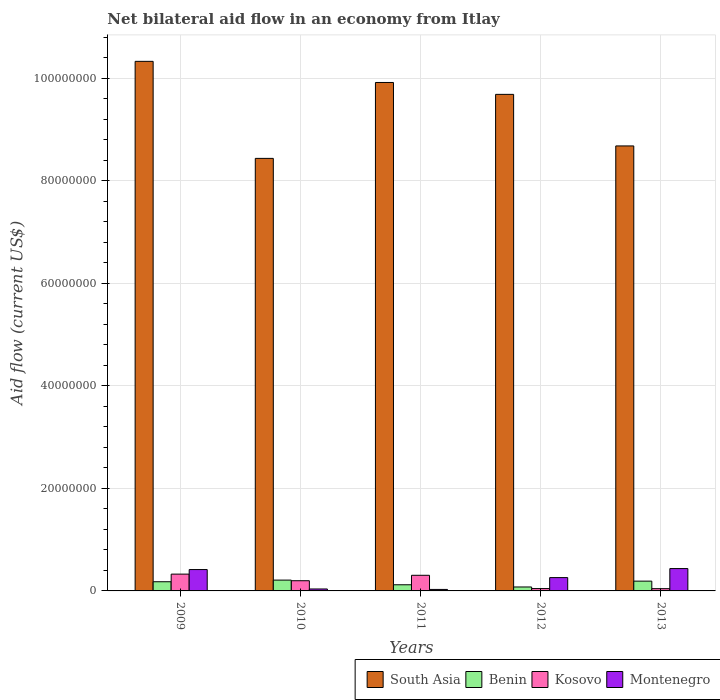How many groups of bars are there?
Provide a succinct answer. 5. How many bars are there on the 5th tick from the left?
Offer a terse response. 4. How many bars are there on the 4th tick from the right?
Your answer should be compact. 4. What is the net bilateral aid flow in Benin in 2009?
Your answer should be very brief. 1.79e+06. Across all years, what is the maximum net bilateral aid flow in Benin?
Keep it short and to the point. 2.11e+06. Across all years, what is the minimum net bilateral aid flow in South Asia?
Keep it short and to the point. 8.44e+07. In which year was the net bilateral aid flow in South Asia maximum?
Ensure brevity in your answer.  2009. What is the total net bilateral aid flow in Kosovo in the graph?
Offer a terse response. 9.22e+06. What is the difference between the net bilateral aid flow in Kosovo in 2011 and that in 2012?
Give a very brief answer. 2.59e+06. What is the difference between the net bilateral aid flow in Montenegro in 2011 and the net bilateral aid flow in Kosovo in 2010?
Provide a succinct answer. -1.70e+06. What is the average net bilateral aid flow in Kosovo per year?
Ensure brevity in your answer.  1.84e+06. In the year 2009, what is the difference between the net bilateral aid flow in Benin and net bilateral aid flow in Kosovo?
Offer a very short reply. -1.49e+06. In how many years, is the net bilateral aid flow in Benin greater than 32000000 US$?
Ensure brevity in your answer.  0. What is the ratio of the net bilateral aid flow in Kosovo in 2009 to that in 2011?
Ensure brevity in your answer.  1.08. Is the net bilateral aid flow in Kosovo in 2010 less than that in 2013?
Offer a very short reply. No. What is the difference between the highest and the second highest net bilateral aid flow in Kosovo?
Offer a terse response. 2.30e+05. What is the difference between the highest and the lowest net bilateral aid flow in Benin?
Your answer should be compact. 1.34e+06. What does the 2nd bar from the left in 2012 represents?
Make the answer very short. Benin. What does the 2nd bar from the right in 2009 represents?
Ensure brevity in your answer.  Kosovo. Are all the bars in the graph horizontal?
Give a very brief answer. No. How many years are there in the graph?
Ensure brevity in your answer.  5. Are the values on the major ticks of Y-axis written in scientific E-notation?
Offer a very short reply. No. How many legend labels are there?
Make the answer very short. 4. How are the legend labels stacked?
Your response must be concise. Horizontal. What is the title of the graph?
Offer a terse response. Net bilateral aid flow in an economy from Itlay. Does "Greece" appear as one of the legend labels in the graph?
Make the answer very short. No. What is the label or title of the X-axis?
Offer a terse response. Years. What is the label or title of the Y-axis?
Ensure brevity in your answer.  Aid flow (current US$). What is the Aid flow (current US$) of South Asia in 2009?
Keep it short and to the point. 1.03e+08. What is the Aid flow (current US$) of Benin in 2009?
Ensure brevity in your answer.  1.79e+06. What is the Aid flow (current US$) of Kosovo in 2009?
Offer a terse response. 3.28e+06. What is the Aid flow (current US$) of Montenegro in 2009?
Provide a succinct answer. 4.17e+06. What is the Aid flow (current US$) in South Asia in 2010?
Your answer should be very brief. 8.44e+07. What is the Aid flow (current US$) in Benin in 2010?
Provide a short and direct response. 2.11e+06. What is the Aid flow (current US$) of Kosovo in 2010?
Provide a succinct answer. 1.99e+06. What is the Aid flow (current US$) of South Asia in 2011?
Offer a terse response. 9.92e+07. What is the Aid flow (current US$) in Benin in 2011?
Your response must be concise. 1.20e+06. What is the Aid flow (current US$) in Kosovo in 2011?
Give a very brief answer. 3.05e+06. What is the Aid flow (current US$) of Montenegro in 2011?
Provide a short and direct response. 2.90e+05. What is the Aid flow (current US$) of South Asia in 2012?
Your response must be concise. 9.69e+07. What is the Aid flow (current US$) of Benin in 2012?
Make the answer very short. 7.70e+05. What is the Aid flow (current US$) in Montenegro in 2012?
Your answer should be very brief. 2.60e+06. What is the Aid flow (current US$) in South Asia in 2013?
Keep it short and to the point. 8.68e+07. What is the Aid flow (current US$) of Benin in 2013?
Your response must be concise. 1.91e+06. What is the Aid flow (current US$) in Montenegro in 2013?
Offer a terse response. 4.36e+06. Across all years, what is the maximum Aid flow (current US$) in South Asia?
Offer a terse response. 1.03e+08. Across all years, what is the maximum Aid flow (current US$) of Benin?
Give a very brief answer. 2.11e+06. Across all years, what is the maximum Aid flow (current US$) of Kosovo?
Make the answer very short. 3.28e+06. Across all years, what is the maximum Aid flow (current US$) in Montenegro?
Keep it short and to the point. 4.36e+06. Across all years, what is the minimum Aid flow (current US$) in South Asia?
Make the answer very short. 8.44e+07. Across all years, what is the minimum Aid flow (current US$) of Benin?
Offer a terse response. 7.70e+05. Across all years, what is the minimum Aid flow (current US$) of Montenegro?
Provide a short and direct response. 2.90e+05. What is the total Aid flow (current US$) in South Asia in the graph?
Offer a terse response. 4.71e+08. What is the total Aid flow (current US$) of Benin in the graph?
Provide a short and direct response. 7.78e+06. What is the total Aid flow (current US$) of Kosovo in the graph?
Give a very brief answer. 9.22e+06. What is the total Aid flow (current US$) of Montenegro in the graph?
Give a very brief answer. 1.18e+07. What is the difference between the Aid flow (current US$) in South Asia in 2009 and that in 2010?
Provide a short and direct response. 1.89e+07. What is the difference between the Aid flow (current US$) in Benin in 2009 and that in 2010?
Your response must be concise. -3.20e+05. What is the difference between the Aid flow (current US$) of Kosovo in 2009 and that in 2010?
Offer a very short reply. 1.29e+06. What is the difference between the Aid flow (current US$) of Montenegro in 2009 and that in 2010?
Your answer should be very brief. 3.79e+06. What is the difference between the Aid flow (current US$) of South Asia in 2009 and that in 2011?
Give a very brief answer. 4.12e+06. What is the difference between the Aid flow (current US$) of Benin in 2009 and that in 2011?
Offer a very short reply. 5.90e+05. What is the difference between the Aid flow (current US$) in Kosovo in 2009 and that in 2011?
Keep it short and to the point. 2.30e+05. What is the difference between the Aid flow (current US$) of Montenegro in 2009 and that in 2011?
Offer a terse response. 3.88e+06. What is the difference between the Aid flow (current US$) of South Asia in 2009 and that in 2012?
Your response must be concise. 6.44e+06. What is the difference between the Aid flow (current US$) of Benin in 2009 and that in 2012?
Offer a very short reply. 1.02e+06. What is the difference between the Aid flow (current US$) in Kosovo in 2009 and that in 2012?
Provide a short and direct response. 2.82e+06. What is the difference between the Aid flow (current US$) of Montenegro in 2009 and that in 2012?
Give a very brief answer. 1.57e+06. What is the difference between the Aid flow (current US$) of South Asia in 2009 and that in 2013?
Make the answer very short. 1.65e+07. What is the difference between the Aid flow (current US$) of Kosovo in 2009 and that in 2013?
Your response must be concise. 2.84e+06. What is the difference between the Aid flow (current US$) of South Asia in 2010 and that in 2011?
Your response must be concise. -1.48e+07. What is the difference between the Aid flow (current US$) in Benin in 2010 and that in 2011?
Your answer should be very brief. 9.10e+05. What is the difference between the Aid flow (current US$) of Kosovo in 2010 and that in 2011?
Provide a short and direct response. -1.06e+06. What is the difference between the Aid flow (current US$) in Montenegro in 2010 and that in 2011?
Your answer should be compact. 9.00e+04. What is the difference between the Aid flow (current US$) of South Asia in 2010 and that in 2012?
Make the answer very short. -1.25e+07. What is the difference between the Aid flow (current US$) of Benin in 2010 and that in 2012?
Keep it short and to the point. 1.34e+06. What is the difference between the Aid flow (current US$) in Kosovo in 2010 and that in 2012?
Give a very brief answer. 1.53e+06. What is the difference between the Aid flow (current US$) of Montenegro in 2010 and that in 2012?
Make the answer very short. -2.22e+06. What is the difference between the Aid flow (current US$) of South Asia in 2010 and that in 2013?
Your answer should be compact. -2.43e+06. What is the difference between the Aid flow (current US$) of Benin in 2010 and that in 2013?
Offer a terse response. 2.00e+05. What is the difference between the Aid flow (current US$) in Kosovo in 2010 and that in 2013?
Make the answer very short. 1.55e+06. What is the difference between the Aid flow (current US$) in Montenegro in 2010 and that in 2013?
Provide a succinct answer. -3.98e+06. What is the difference between the Aid flow (current US$) of South Asia in 2011 and that in 2012?
Give a very brief answer. 2.32e+06. What is the difference between the Aid flow (current US$) in Benin in 2011 and that in 2012?
Make the answer very short. 4.30e+05. What is the difference between the Aid flow (current US$) in Kosovo in 2011 and that in 2012?
Make the answer very short. 2.59e+06. What is the difference between the Aid flow (current US$) of Montenegro in 2011 and that in 2012?
Your answer should be very brief. -2.31e+06. What is the difference between the Aid flow (current US$) in South Asia in 2011 and that in 2013?
Your answer should be very brief. 1.24e+07. What is the difference between the Aid flow (current US$) in Benin in 2011 and that in 2013?
Give a very brief answer. -7.10e+05. What is the difference between the Aid flow (current US$) of Kosovo in 2011 and that in 2013?
Your answer should be compact. 2.61e+06. What is the difference between the Aid flow (current US$) of Montenegro in 2011 and that in 2013?
Your response must be concise. -4.07e+06. What is the difference between the Aid flow (current US$) of South Asia in 2012 and that in 2013?
Make the answer very short. 1.01e+07. What is the difference between the Aid flow (current US$) in Benin in 2012 and that in 2013?
Offer a terse response. -1.14e+06. What is the difference between the Aid flow (current US$) in Montenegro in 2012 and that in 2013?
Your answer should be compact. -1.76e+06. What is the difference between the Aid flow (current US$) of South Asia in 2009 and the Aid flow (current US$) of Benin in 2010?
Your answer should be compact. 1.01e+08. What is the difference between the Aid flow (current US$) in South Asia in 2009 and the Aid flow (current US$) in Kosovo in 2010?
Offer a terse response. 1.01e+08. What is the difference between the Aid flow (current US$) of South Asia in 2009 and the Aid flow (current US$) of Montenegro in 2010?
Your answer should be compact. 1.03e+08. What is the difference between the Aid flow (current US$) of Benin in 2009 and the Aid flow (current US$) of Kosovo in 2010?
Offer a terse response. -2.00e+05. What is the difference between the Aid flow (current US$) of Benin in 2009 and the Aid flow (current US$) of Montenegro in 2010?
Make the answer very short. 1.41e+06. What is the difference between the Aid flow (current US$) in Kosovo in 2009 and the Aid flow (current US$) in Montenegro in 2010?
Provide a short and direct response. 2.90e+06. What is the difference between the Aid flow (current US$) of South Asia in 2009 and the Aid flow (current US$) of Benin in 2011?
Your answer should be compact. 1.02e+08. What is the difference between the Aid flow (current US$) in South Asia in 2009 and the Aid flow (current US$) in Kosovo in 2011?
Offer a very short reply. 1.00e+08. What is the difference between the Aid flow (current US$) of South Asia in 2009 and the Aid flow (current US$) of Montenegro in 2011?
Your answer should be compact. 1.03e+08. What is the difference between the Aid flow (current US$) in Benin in 2009 and the Aid flow (current US$) in Kosovo in 2011?
Give a very brief answer. -1.26e+06. What is the difference between the Aid flow (current US$) of Benin in 2009 and the Aid flow (current US$) of Montenegro in 2011?
Provide a succinct answer. 1.50e+06. What is the difference between the Aid flow (current US$) in Kosovo in 2009 and the Aid flow (current US$) in Montenegro in 2011?
Provide a succinct answer. 2.99e+06. What is the difference between the Aid flow (current US$) in South Asia in 2009 and the Aid flow (current US$) in Benin in 2012?
Your answer should be compact. 1.03e+08. What is the difference between the Aid flow (current US$) in South Asia in 2009 and the Aid flow (current US$) in Kosovo in 2012?
Give a very brief answer. 1.03e+08. What is the difference between the Aid flow (current US$) of South Asia in 2009 and the Aid flow (current US$) of Montenegro in 2012?
Make the answer very short. 1.01e+08. What is the difference between the Aid flow (current US$) in Benin in 2009 and the Aid flow (current US$) in Kosovo in 2012?
Keep it short and to the point. 1.33e+06. What is the difference between the Aid flow (current US$) of Benin in 2009 and the Aid flow (current US$) of Montenegro in 2012?
Your answer should be compact. -8.10e+05. What is the difference between the Aid flow (current US$) in Kosovo in 2009 and the Aid flow (current US$) in Montenegro in 2012?
Your answer should be compact. 6.80e+05. What is the difference between the Aid flow (current US$) in South Asia in 2009 and the Aid flow (current US$) in Benin in 2013?
Your answer should be compact. 1.01e+08. What is the difference between the Aid flow (current US$) of South Asia in 2009 and the Aid flow (current US$) of Kosovo in 2013?
Offer a terse response. 1.03e+08. What is the difference between the Aid flow (current US$) of South Asia in 2009 and the Aid flow (current US$) of Montenegro in 2013?
Make the answer very short. 9.90e+07. What is the difference between the Aid flow (current US$) of Benin in 2009 and the Aid flow (current US$) of Kosovo in 2013?
Your answer should be compact. 1.35e+06. What is the difference between the Aid flow (current US$) of Benin in 2009 and the Aid flow (current US$) of Montenegro in 2013?
Your answer should be compact. -2.57e+06. What is the difference between the Aid flow (current US$) of Kosovo in 2009 and the Aid flow (current US$) of Montenegro in 2013?
Offer a very short reply. -1.08e+06. What is the difference between the Aid flow (current US$) of South Asia in 2010 and the Aid flow (current US$) of Benin in 2011?
Your answer should be very brief. 8.32e+07. What is the difference between the Aid flow (current US$) of South Asia in 2010 and the Aid flow (current US$) of Kosovo in 2011?
Give a very brief answer. 8.13e+07. What is the difference between the Aid flow (current US$) in South Asia in 2010 and the Aid flow (current US$) in Montenegro in 2011?
Your answer should be very brief. 8.41e+07. What is the difference between the Aid flow (current US$) in Benin in 2010 and the Aid flow (current US$) in Kosovo in 2011?
Provide a short and direct response. -9.40e+05. What is the difference between the Aid flow (current US$) in Benin in 2010 and the Aid flow (current US$) in Montenegro in 2011?
Offer a terse response. 1.82e+06. What is the difference between the Aid flow (current US$) of Kosovo in 2010 and the Aid flow (current US$) of Montenegro in 2011?
Your answer should be very brief. 1.70e+06. What is the difference between the Aid flow (current US$) of South Asia in 2010 and the Aid flow (current US$) of Benin in 2012?
Your answer should be very brief. 8.36e+07. What is the difference between the Aid flow (current US$) of South Asia in 2010 and the Aid flow (current US$) of Kosovo in 2012?
Make the answer very short. 8.39e+07. What is the difference between the Aid flow (current US$) of South Asia in 2010 and the Aid flow (current US$) of Montenegro in 2012?
Give a very brief answer. 8.18e+07. What is the difference between the Aid flow (current US$) in Benin in 2010 and the Aid flow (current US$) in Kosovo in 2012?
Your answer should be very brief. 1.65e+06. What is the difference between the Aid flow (current US$) of Benin in 2010 and the Aid flow (current US$) of Montenegro in 2012?
Your answer should be compact. -4.90e+05. What is the difference between the Aid flow (current US$) in Kosovo in 2010 and the Aid flow (current US$) in Montenegro in 2012?
Keep it short and to the point. -6.10e+05. What is the difference between the Aid flow (current US$) in South Asia in 2010 and the Aid flow (current US$) in Benin in 2013?
Your response must be concise. 8.25e+07. What is the difference between the Aid flow (current US$) in South Asia in 2010 and the Aid flow (current US$) in Kosovo in 2013?
Provide a short and direct response. 8.40e+07. What is the difference between the Aid flow (current US$) in South Asia in 2010 and the Aid flow (current US$) in Montenegro in 2013?
Your response must be concise. 8.00e+07. What is the difference between the Aid flow (current US$) of Benin in 2010 and the Aid flow (current US$) of Kosovo in 2013?
Provide a short and direct response. 1.67e+06. What is the difference between the Aid flow (current US$) in Benin in 2010 and the Aid flow (current US$) in Montenegro in 2013?
Your answer should be compact. -2.25e+06. What is the difference between the Aid flow (current US$) of Kosovo in 2010 and the Aid flow (current US$) of Montenegro in 2013?
Your answer should be very brief. -2.37e+06. What is the difference between the Aid flow (current US$) of South Asia in 2011 and the Aid flow (current US$) of Benin in 2012?
Offer a very short reply. 9.84e+07. What is the difference between the Aid flow (current US$) of South Asia in 2011 and the Aid flow (current US$) of Kosovo in 2012?
Provide a short and direct response. 9.87e+07. What is the difference between the Aid flow (current US$) of South Asia in 2011 and the Aid flow (current US$) of Montenegro in 2012?
Your answer should be compact. 9.66e+07. What is the difference between the Aid flow (current US$) in Benin in 2011 and the Aid flow (current US$) in Kosovo in 2012?
Give a very brief answer. 7.40e+05. What is the difference between the Aid flow (current US$) of Benin in 2011 and the Aid flow (current US$) of Montenegro in 2012?
Your answer should be very brief. -1.40e+06. What is the difference between the Aid flow (current US$) in Kosovo in 2011 and the Aid flow (current US$) in Montenegro in 2012?
Provide a succinct answer. 4.50e+05. What is the difference between the Aid flow (current US$) in South Asia in 2011 and the Aid flow (current US$) in Benin in 2013?
Provide a short and direct response. 9.73e+07. What is the difference between the Aid flow (current US$) in South Asia in 2011 and the Aid flow (current US$) in Kosovo in 2013?
Ensure brevity in your answer.  9.88e+07. What is the difference between the Aid flow (current US$) of South Asia in 2011 and the Aid flow (current US$) of Montenegro in 2013?
Ensure brevity in your answer.  9.48e+07. What is the difference between the Aid flow (current US$) in Benin in 2011 and the Aid flow (current US$) in Kosovo in 2013?
Offer a terse response. 7.60e+05. What is the difference between the Aid flow (current US$) in Benin in 2011 and the Aid flow (current US$) in Montenegro in 2013?
Your answer should be very brief. -3.16e+06. What is the difference between the Aid flow (current US$) of Kosovo in 2011 and the Aid flow (current US$) of Montenegro in 2013?
Give a very brief answer. -1.31e+06. What is the difference between the Aid flow (current US$) in South Asia in 2012 and the Aid flow (current US$) in Benin in 2013?
Give a very brief answer. 9.50e+07. What is the difference between the Aid flow (current US$) of South Asia in 2012 and the Aid flow (current US$) of Kosovo in 2013?
Offer a very short reply. 9.64e+07. What is the difference between the Aid flow (current US$) of South Asia in 2012 and the Aid flow (current US$) of Montenegro in 2013?
Provide a short and direct response. 9.25e+07. What is the difference between the Aid flow (current US$) in Benin in 2012 and the Aid flow (current US$) in Kosovo in 2013?
Make the answer very short. 3.30e+05. What is the difference between the Aid flow (current US$) of Benin in 2012 and the Aid flow (current US$) of Montenegro in 2013?
Your answer should be very brief. -3.59e+06. What is the difference between the Aid flow (current US$) in Kosovo in 2012 and the Aid flow (current US$) in Montenegro in 2013?
Give a very brief answer. -3.90e+06. What is the average Aid flow (current US$) of South Asia per year?
Your answer should be compact. 9.41e+07. What is the average Aid flow (current US$) of Benin per year?
Your answer should be compact. 1.56e+06. What is the average Aid flow (current US$) in Kosovo per year?
Make the answer very short. 1.84e+06. What is the average Aid flow (current US$) in Montenegro per year?
Ensure brevity in your answer.  2.36e+06. In the year 2009, what is the difference between the Aid flow (current US$) of South Asia and Aid flow (current US$) of Benin?
Provide a short and direct response. 1.02e+08. In the year 2009, what is the difference between the Aid flow (current US$) of South Asia and Aid flow (current US$) of Kosovo?
Your answer should be compact. 1.00e+08. In the year 2009, what is the difference between the Aid flow (current US$) in South Asia and Aid flow (current US$) in Montenegro?
Your answer should be compact. 9.92e+07. In the year 2009, what is the difference between the Aid flow (current US$) of Benin and Aid flow (current US$) of Kosovo?
Ensure brevity in your answer.  -1.49e+06. In the year 2009, what is the difference between the Aid flow (current US$) in Benin and Aid flow (current US$) in Montenegro?
Offer a very short reply. -2.38e+06. In the year 2009, what is the difference between the Aid flow (current US$) of Kosovo and Aid flow (current US$) of Montenegro?
Offer a very short reply. -8.90e+05. In the year 2010, what is the difference between the Aid flow (current US$) of South Asia and Aid flow (current US$) of Benin?
Keep it short and to the point. 8.23e+07. In the year 2010, what is the difference between the Aid flow (current US$) in South Asia and Aid flow (current US$) in Kosovo?
Offer a very short reply. 8.24e+07. In the year 2010, what is the difference between the Aid flow (current US$) of South Asia and Aid flow (current US$) of Montenegro?
Give a very brief answer. 8.40e+07. In the year 2010, what is the difference between the Aid flow (current US$) in Benin and Aid flow (current US$) in Kosovo?
Provide a succinct answer. 1.20e+05. In the year 2010, what is the difference between the Aid flow (current US$) of Benin and Aid flow (current US$) of Montenegro?
Offer a terse response. 1.73e+06. In the year 2010, what is the difference between the Aid flow (current US$) in Kosovo and Aid flow (current US$) in Montenegro?
Your response must be concise. 1.61e+06. In the year 2011, what is the difference between the Aid flow (current US$) in South Asia and Aid flow (current US$) in Benin?
Your response must be concise. 9.80e+07. In the year 2011, what is the difference between the Aid flow (current US$) in South Asia and Aid flow (current US$) in Kosovo?
Ensure brevity in your answer.  9.62e+07. In the year 2011, what is the difference between the Aid flow (current US$) in South Asia and Aid flow (current US$) in Montenegro?
Your answer should be compact. 9.89e+07. In the year 2011, what is the difference between the Aid flow (current US$) of Benin and Aid flow (current US$) of Kosovo?
Your answer should be very brief. -1.85e+06. In the year 2011, what is the difference between the Aid flow (current US$) in Benin and Aid flow (current US$) in Montenegro?
Keep it short and to the point. 9.10e+05. In the year 2011, what is the difference between the Aid flow (current US$) in Kosovo and Aid flow (current US$) in Montenegro?
Your answer should be very brief. 2.76e+06. In the year 2012, what is the difference between the Aid flow (current US$) of South Asia and Aid flow (current US$) of Benin?
Offer a terse response. 9.61e+07. In the year 2012, what is the difference between the Aid flow (current US$) in South Asia and Aid flow (current US$) in Kosovo?
Give a very brief answer. 9.64e+07. In the year 2012, what is the difference between the Aid flow (current US$) of South Asia and Aid flow (current US$) of Montenegro?
Ensure brevity in your answer.  9.43e+07. In the year 2012, what is the difference between the Aid flow (current US$) of Benin and Aid flow (current US$) of Montenegro?
Keep it short and to the point. -1.83e+06. In the year 2012, what is the difference between the Aid flow (current US$) in Kosovo and Aid flow (current US$) in Montenegro?
Provide a succinct answer. -2.14e+06. In the year 2013, what is the difference between the Aid flow (current US$) in South Asia and Aid flow (current US$) in Benin?
Your response must be concise. 8.49e+07. In the year 2013, what is the difference between the Aid flow (current US$) of South Asia and Aid flow (current US$) of Kosovo?
Give a very brief answer. 8.64e+07. In the year 2013, what is the difference between the Aid flow (current US$) in South Asia and Aid flow (current US$) in Montenegro?
Keep it short and to the point. 8.25e+07. In the year 2013, what is the difference between the Aid flow (current US$) of Benin and Aid flow (current US$) of Kosovo?
Your response must be concise. 1.47e+06. In the year 2013, what is the difference between the Aid flow (current US$) of Benin and Aid flow (current US$) of Montenegro?
Give a very brief answer. -2.45e+06. In the year 2013, what is the difference between the Aid flow (current US$) of Kosovo and Aid flow (current US$) of Montenegro?
Provide a succinct answer. -3.92e+06. What is the ratio of the Aid flow (current US$) in South Asia in 2009 to that in 2010?
Keep it short and to the point. 1.22. What is the ratio of the Aid flow (current US$) in Benin in 2009 to that in 2010?
Ensure brevity in your answer.  0.85. What is the ratio of the Aid flow (current US$) in Kosovo in 2009 to that in 2010?
Give a very brief answer. 1.65. What is the ratio of the Aid flow (current US$) of Montenegro in 2009 to that in 2010?
Keep it short and to the point. 10.97. What is the ratio of the Aid flow (current US$) in South Asia in 2009 to that in 2011?
Provide a succinct answer. 1.04. What is the ratio of the Aid flow (current US$) of Benin in 2009 to that in 2011?
Your response must be concise. 1.49. What is the ratio of the Aid flow (current US$) of Kosovo in 2009 to that in 2011?
Offer a very short reply. 1.08. What is the ratio of the Aid flow (current US$) in Montenegro in 2009 to that in 2011?
Your response must be concise. 14.38. What is the ratio of the Aid flow (current US$) of South Asia in 2009 to that in 2012?
Make the answer very short. 1.07. What is the ratio of the Aid flow (current US$) of Benin in 2009 to that in 2012?
Offer a very short reply. 2.32. What is the ratio of the Aid flow (current US$) of Kosovo in 2009 to that in 2012?
Ensure brevity in your answer.  7.13. What is the ratio of the Aid flow (current US$) of Montenegro in 2009 to that in 2012?
Make the answer very short. 1.6. What is the ratio of the Aid flow (current US$) in South Asia in 2009 to that in 2013?
Keep it short and to the point. 1.19. What is the ratio of the Aid flow (current US$) of Benin in 2009 to that in 2013?
Your response must be concise. 0.94. What is the ratio of the Aid flow (current US$) in Kosovo in 2009 to that in 2013?
Your answer should be very brief. 7.45. What is the ratio of the Aid flow (current US$) in Montenegro in 2009 to that in 2013?
Make the answer very short. 0.96. What is the ratio of the Aid flow (current US$) of South Asia in 2010 to that in 2011?
Provide a succinct answer. 0.85. What is the ratio of the Aid flow (current US$) in Benin in 2010 to that in 2011?
Ensure brevity in your answer.  1.76. What is the ratio of the Aid flow (current US$) in Kosovo in 2010 to that in 2011?
Give a very brief answer. 0.65. What is the ratio of the Aid flow (current US$) in Montenegro in 2010 to that in 2011?
Provide a succinct answer. 1.31. What is the ratio of the Aid flow (current US$) in South Asia in 2010 to that in 2012?
Your answer should be compact. 0.87. What is the ratio of the Aid flow (current US$) in Benin in 2010 to that in 2012?
Offer a terse response. 2.74. What is the ratio of the Aid flow (current US$) of Kosovo in 2010 to that in 2012?
Your answer should be very brief. 4.33. What is the ratio of the Aid flow (current US$) in Montenegro in 2010 to that in 2012?
Provide a short and direct response. 0.15. What is the ratio of the Aid flow (current US$) of Benin in 2010 to that in 2013?
Your answer should be compact. 1.1. What is the ratio of the Aid flow (current US$) in Kosovo in 2010 to that in 2013?
Your answer should be compact. 4.52. What is the ratio of the Aid flow (current US$) in Montenegro in 2010 to that in 2013?
Offer a very short reply. 0.09. What is the ratio of the Aid flow (current US$) of South Asia in 2011 to that in 2012?
Ensure brevity in your answer.  1.02. What is the ratio of the Aid flow (current US$) in Benin in 2011 to that in 2012?
Ensure brevity in your answer.  1.56. What is the ratio of the Aid flow (current US$) in Kosovo in 2011 to that in 2012?
Provide a short and direct response. 6.63. What is the ratio of the Aid flow (current US$) of Montenegro in 2011 to that in 2012?
Your response must be concise. 0.11. What is the ratio of the Aid flow (current US$) in South Asia in 2011 to that in 2013?
Make the answer very short. 1.14. What is the ratio of the Aid flow (current US$) of Benin in 2011 to that in 2013?
Provide a succinct answer. 0.63. What is the ratio of the Aid flow (current US$) of Kosovo in 2011 to that in 2013?
Your answer should be very brief. 6.93. What is the ratio of the Aid flow (current US$) of Montenegro in 2011 to that in 2013?
Your answer should be very brief. 0.07. What is the ratio of the Aid flow (current US$) of South Asia in 2012 to that in 2013?
Give a very brief answer. 1.12. What is the ratio of the Aid flow (current US$) of Benin in 2012 to that in 2013?
Your answer should be compact. 0.4. What is the ratio of the Aid flow (current US$) of Kosovo in 2012 to that in 2013?
Your response must be concise. 1.05. What is the ratio of the Aid flow (current US$) in Montenegro in 2012 to that in 2013?
Ensure brevity in your answer.  0.6. What is the difference between the highest and the second highest Aid flow (current US$) in South Asia?
Provide a succinct answer. 4.12e+06. What is the difference between the highest and the second highest Aid flow (current US$) of Kosovo?
Your answer should be compact. 2.30e+05. What is the difference between the highest and the second highest Aid flow (current US$) of Montenegro?
Ensure brevity in your answer.  1.90e+05. What is the difference between the highest and the lowest Aid flow (current US$) in South Asia?
Give a very brief answer. 1.89e+07. What is the difference between the highest and the lowest Aid flow (current US$) in Benin?
Your answer should be compact. 1.34e+06. What is the difference between the highest and the lowest Aid flow (current US$) of Kosovo?
Keep it short and to the point. 2.84e+06. What is the difference between the highest and the lowest Aid flow (current US$) of Montenegro?
Your answer should be compact. 4.07e+06. 